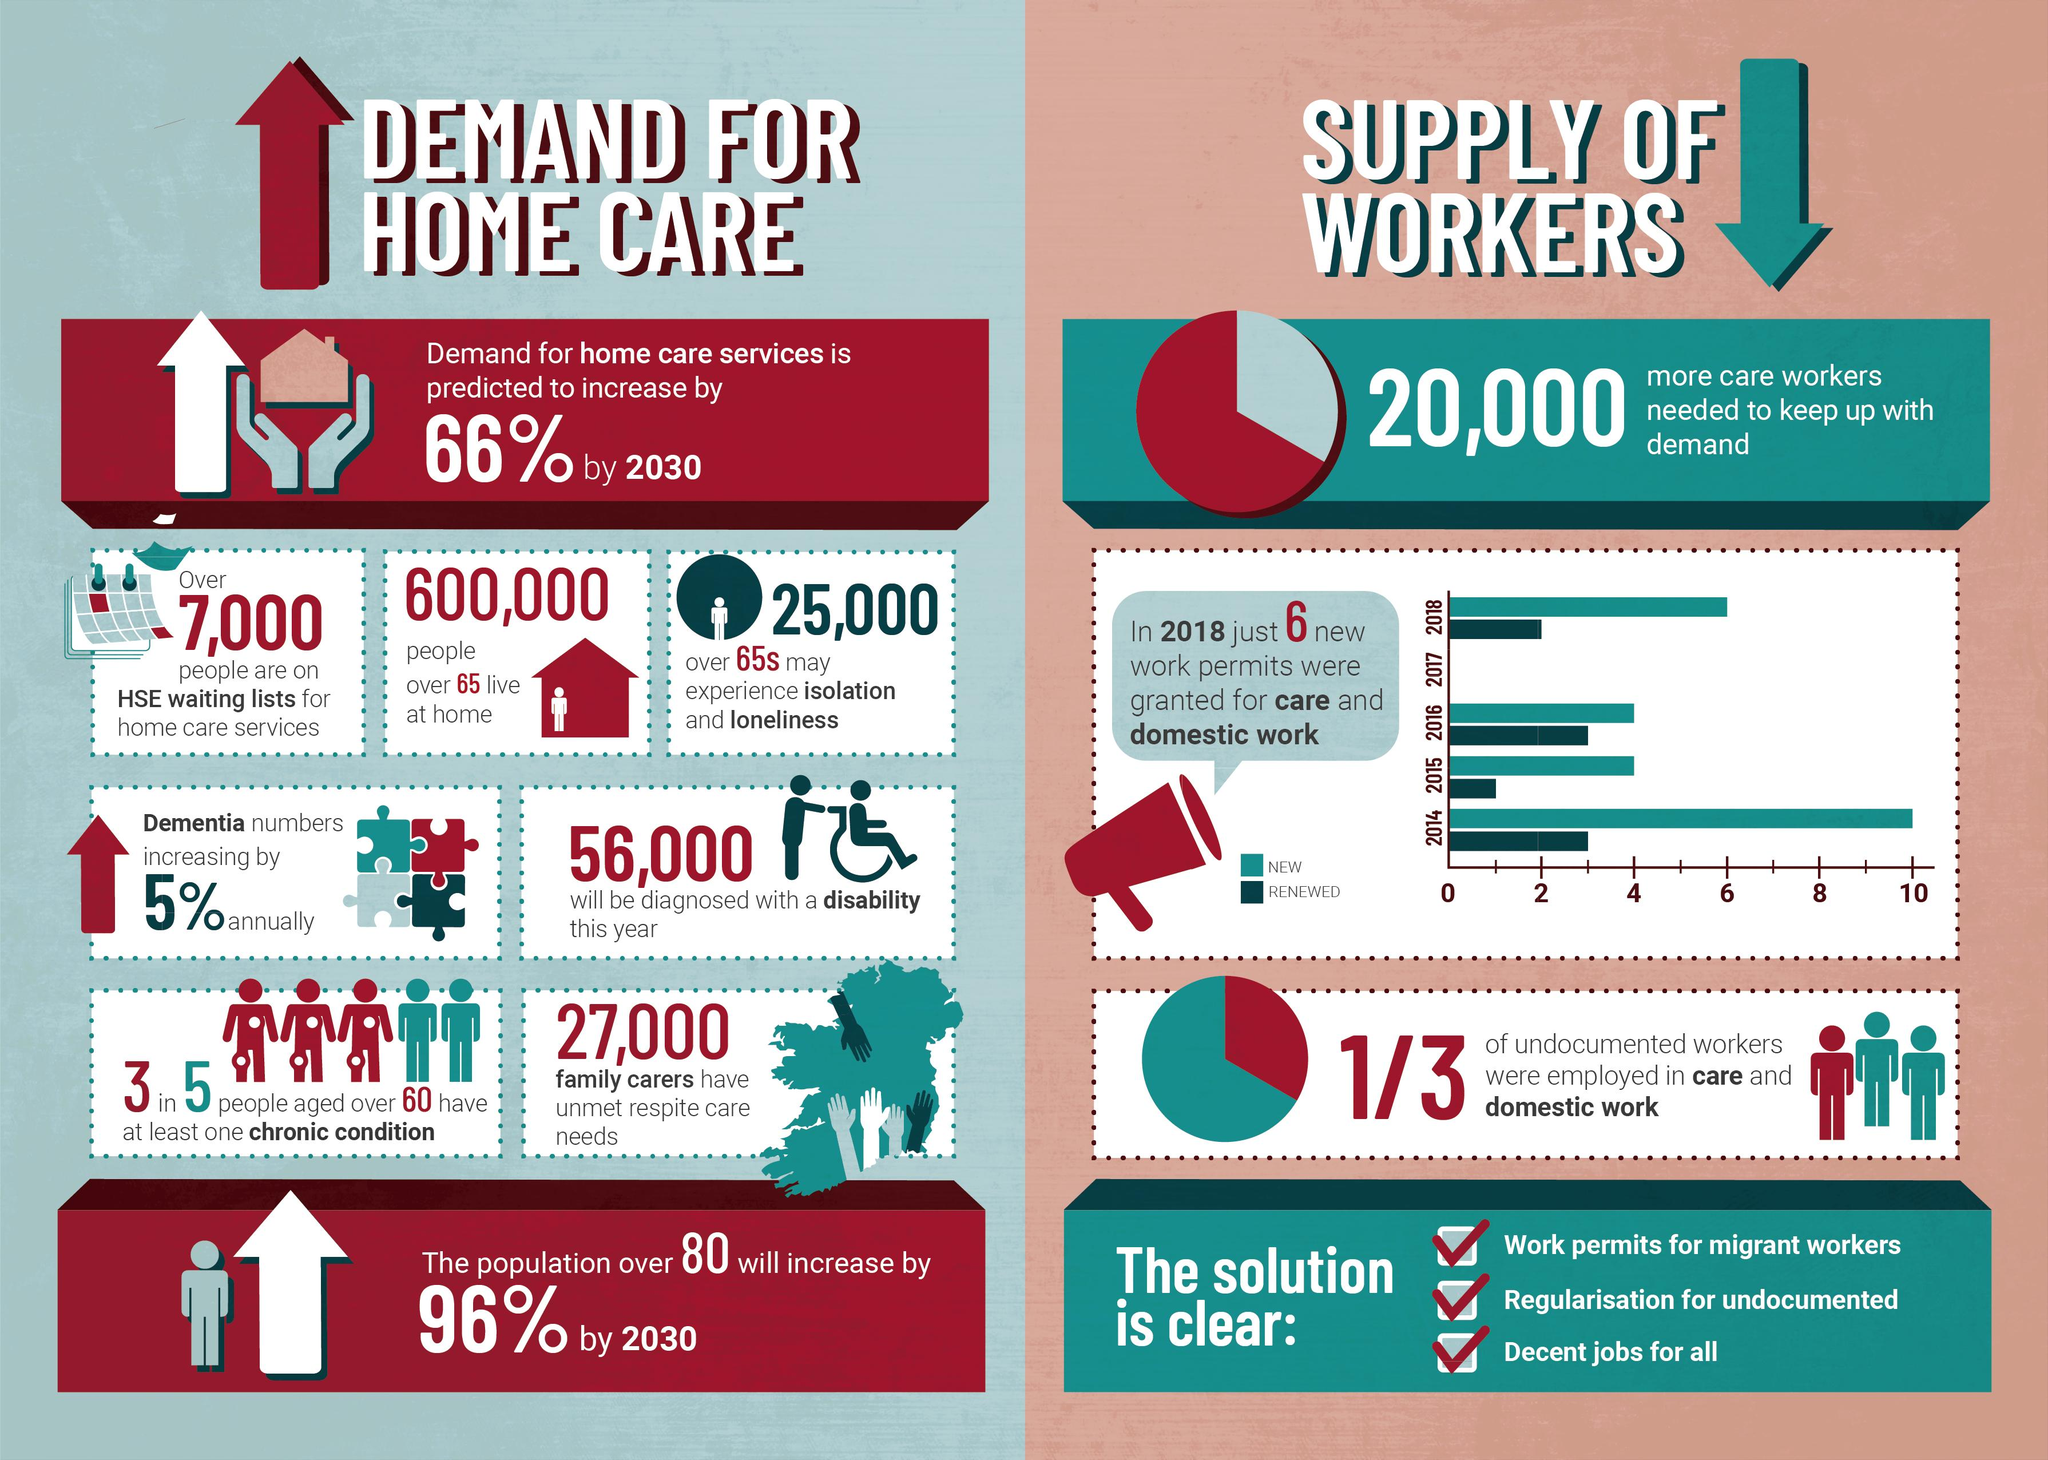Specify some key components in this picture. The number of home care personnel required in 2030 is 34. In the year 2014, 3 work permits were renewed. In the year 2016, 4 new work permits were allowed. In the year 2016, a total of 3 work permits were renewed. In the year 2015, 4 new work permits were allowed. 